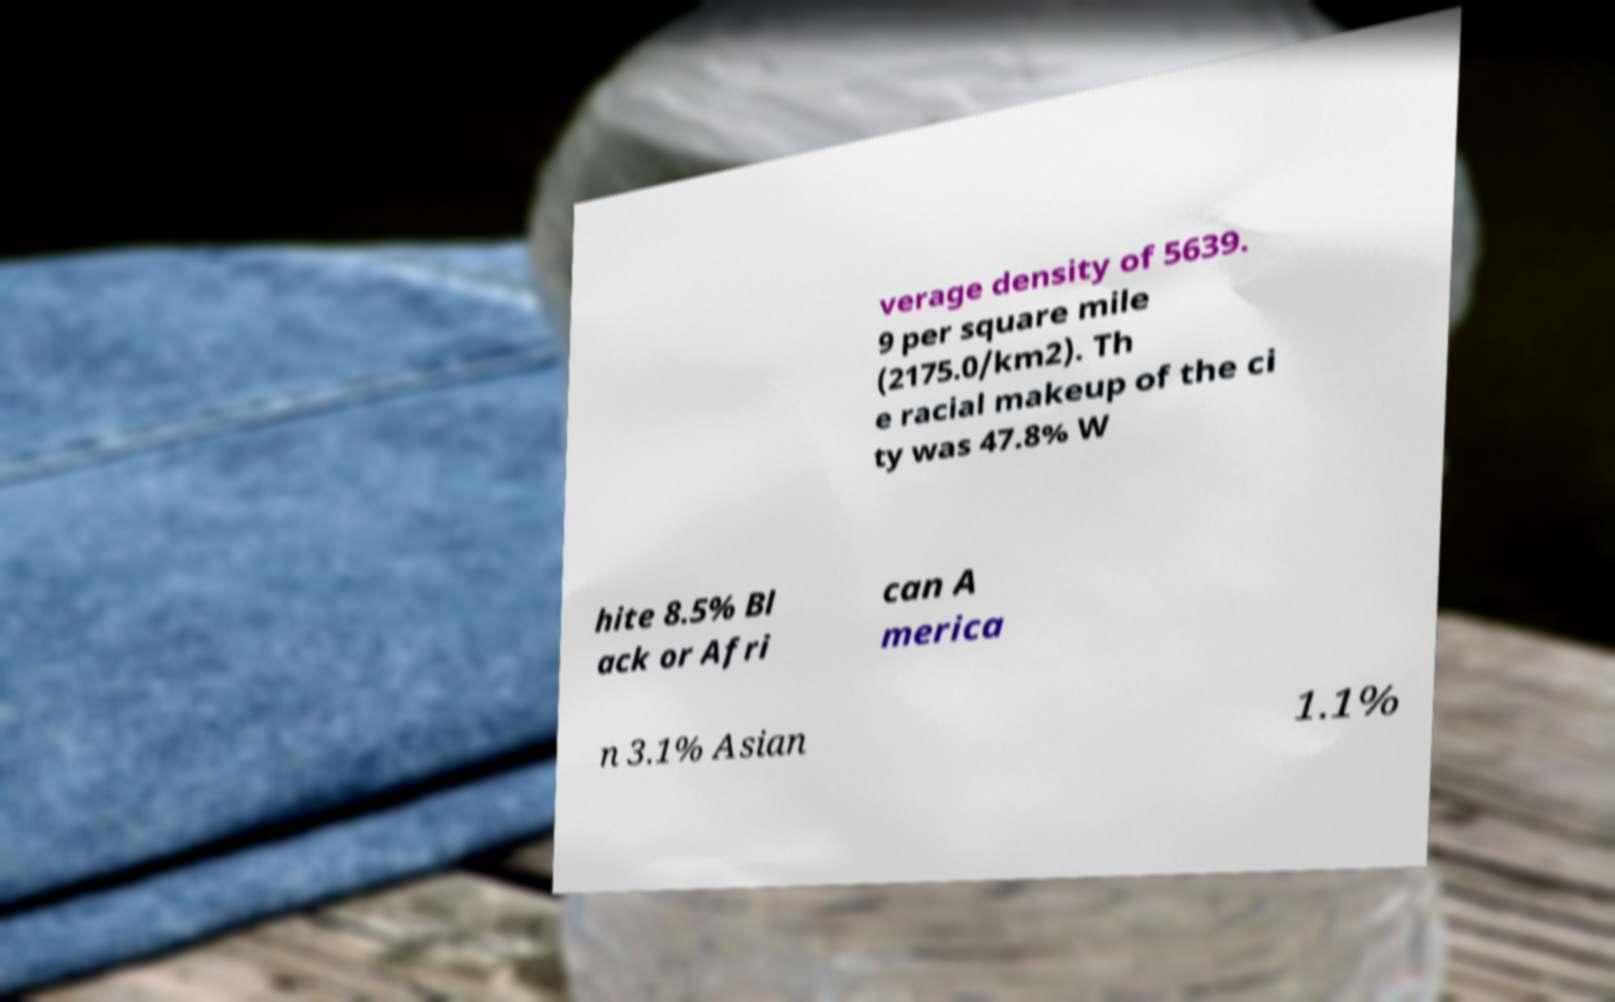Could you extract and type out the text from this image? verage density of 5639. 9 per square mile (2175.0/km2). Th e racial makeup of the ci ty was 47.8% W hite 8.5% Bl ack or Afri can A merica n 3.1% Asian 1.1% 